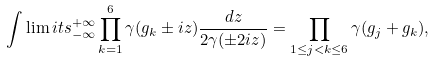Convert formula to latex. <formula><loc_0><loc_0><loc_500><loc_500>\int \lim i t s ^ { + \infty } _ { - \infty } \prod _ { k = 1 } ^ { 6 } \gamma ( g _ { k } \pm i z ) \frac { d z } { 2 \gamma ( \pm 2 i z ) } = \prod _ { 1 \leq j < k \leq 6 } \gamma ( g _ { j } + g _ { k } ) ,</formula> 